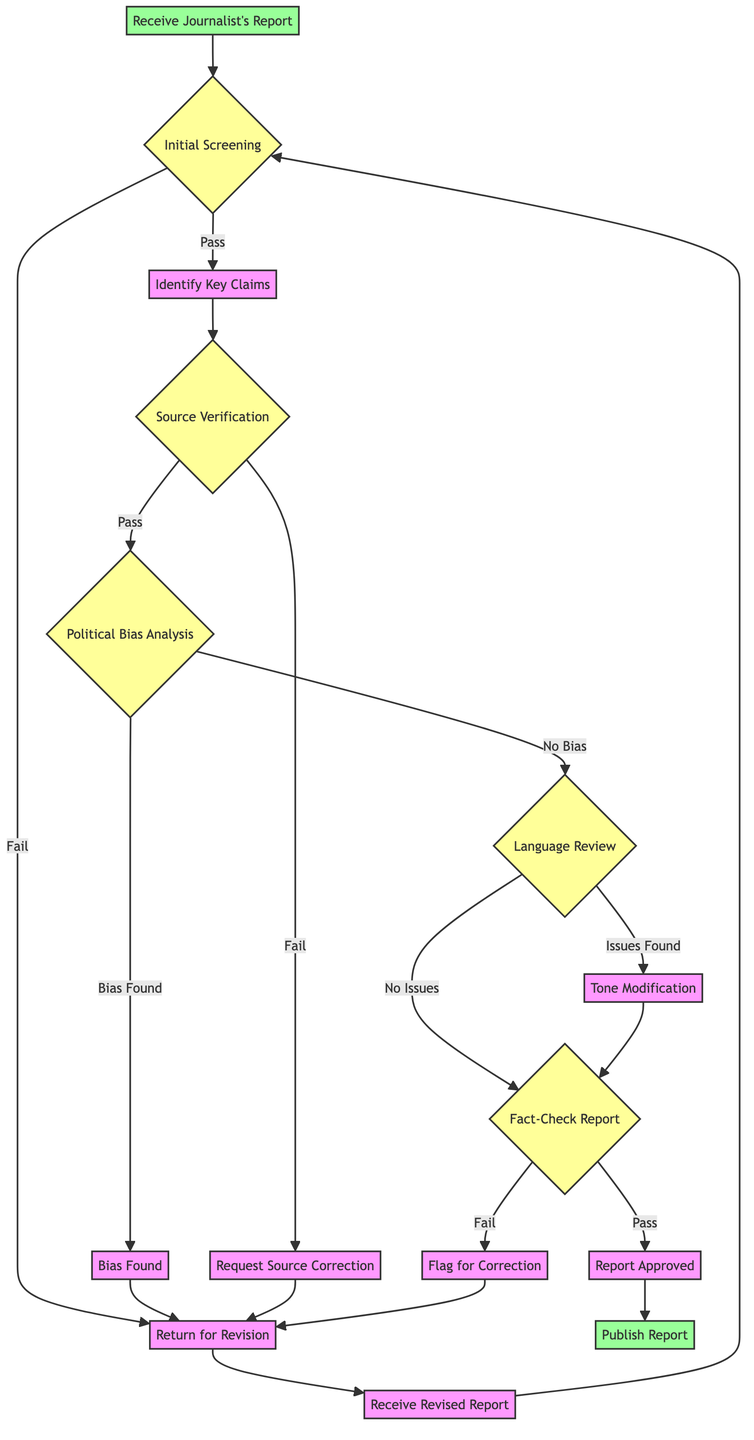What is the first step in the workflow? The first node in the flowchart is "Receive Journalist's Report," which indicates that this is the initial step of the process.
Answer: Receive Journalist's Report What happens if the initial screening fails? According to the flowchart, if the initial screening fails, it leads to "Return for Revision." This indicates that the report will be sent back for corrections.
Answer: Return for Revision How many main processes are there from the initial screening to publication? The flowchart includes a sequence of steps between "Initial Screening" and "Publish Report," revealing five distinct processes from the initial screening through fact-checking and approval.
Answer: Five What follows after "Source Verification" if the sources are verified? If the sources in "Source Verification" are verified, the workflow then proceeds to "Political Bias Analysis" as shown in the diagram.
Answer: Political Bias Analysis What action is taken if a significant political bias is detected? The flowchart indicates that if a significant political bias is found during the "Political Bias Analysis," it leads to the "Bias Found" node, which subsequently returns the report for revision.
Answer: Return for Revision What is the outcome if the fact-check report passes? If the "Fact-Check Report" passes, the next step is labeled as "Report Approved," allowing for the final approval of the report for publication.
Answer: Report Approved What do you do if issues are found during the language review? The flowchart specifies that if issues are found during the "Language Review," it leads to "Tone Modification," where modifications are requested to neutralize the tone of the report.
Answer: Tone Modification What is the final step in the fact-checking workflow? The last node in the flowchart is "Publish Report," which signifies the completion of the fact-checking workflow when the report is published after approval.
Answer: Publish Report What node signifies the return to initial screening? The flowchart shows that "Receive Revised Report" leads back to "Initial Screening," indicating that the revised report undergoes screening once again.
Answer: Initial Screening 